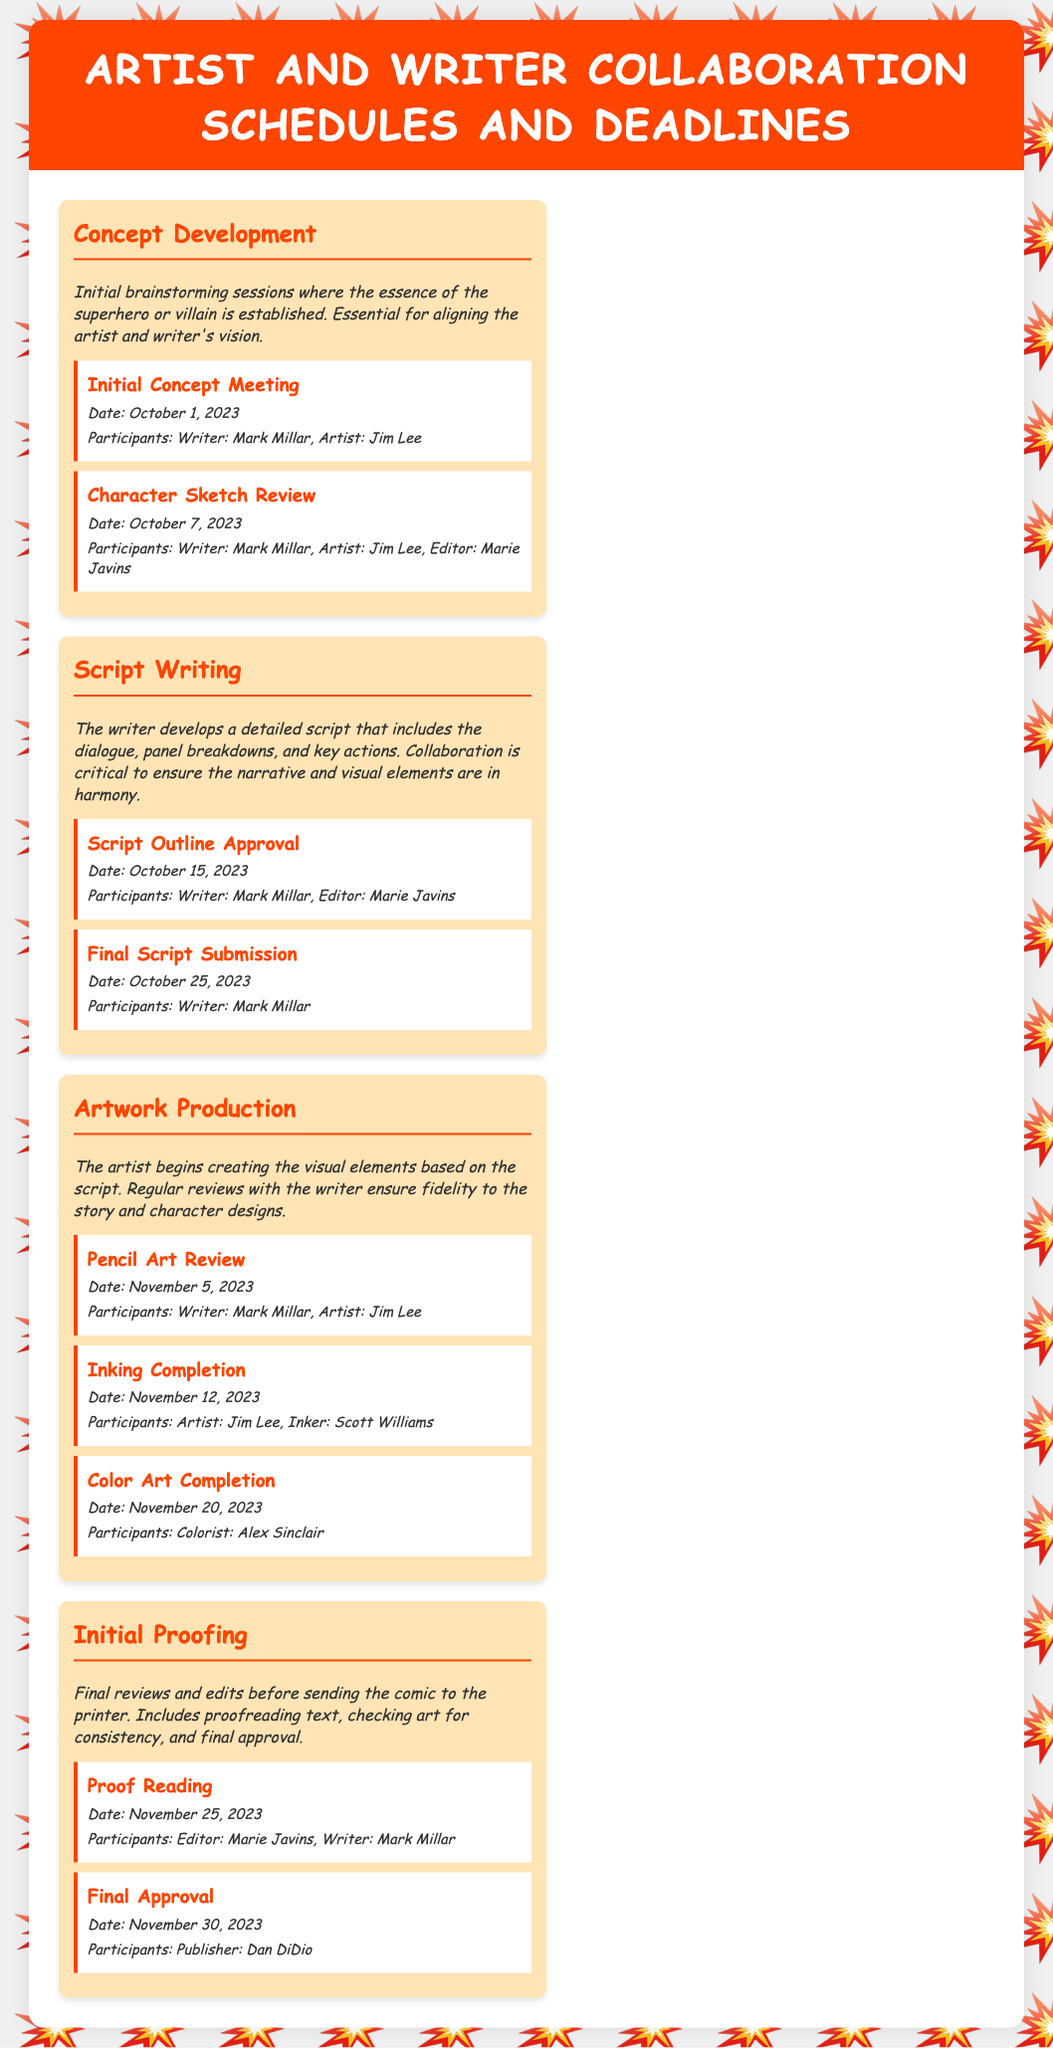What is the first milestone in Concept Development? The first milestone in Concept Development is the Initial Concept Meeting held on October 1, 2023.
Answer: Initial Concept Meeting Who are the participants in the Color Art Completion milestone? The Color Art Completion milestone involves only the colorist. The document specifies the participant as Colorist: Alex Sinclair.
Answer: Alex Sinclair What is the date for the Script Outline Approval? The Script Outline Approval is scheduled for October 15, 2023.
Answer: October 15, 2023 How many phases are there in the document? The document outlines four distinct phases in the collaboration schedule.
Answer: Four Who gives the Final Approval? The Final Approval is given by the Publisher. The document names the participant as Publisher: Dan DiDio.
Answer: Dan DiDio What is the primary purpose of the Initial Proofing phase? The Initial Proofing phase involves final reviews and edits before printing the comic.
Answer: Final reviews and edits What type of document is this? This is a calendar outlining collaboration schedules and deadlines for comic book artists and writers.
Answer: Calendar When does the Inking Completion milestone take place? The Inking Completion milestone takes place on November 12, 2023.
Answer: November 12, 2023 